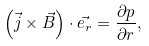<formula> <loc_0><loc_0><loc_500><loc_500>\left ( \vec { j } \times \vec { B } \right ) \cdot \vec { { e } _ { r } } = \frac { \partial p } { \partial r } ,</formula> 